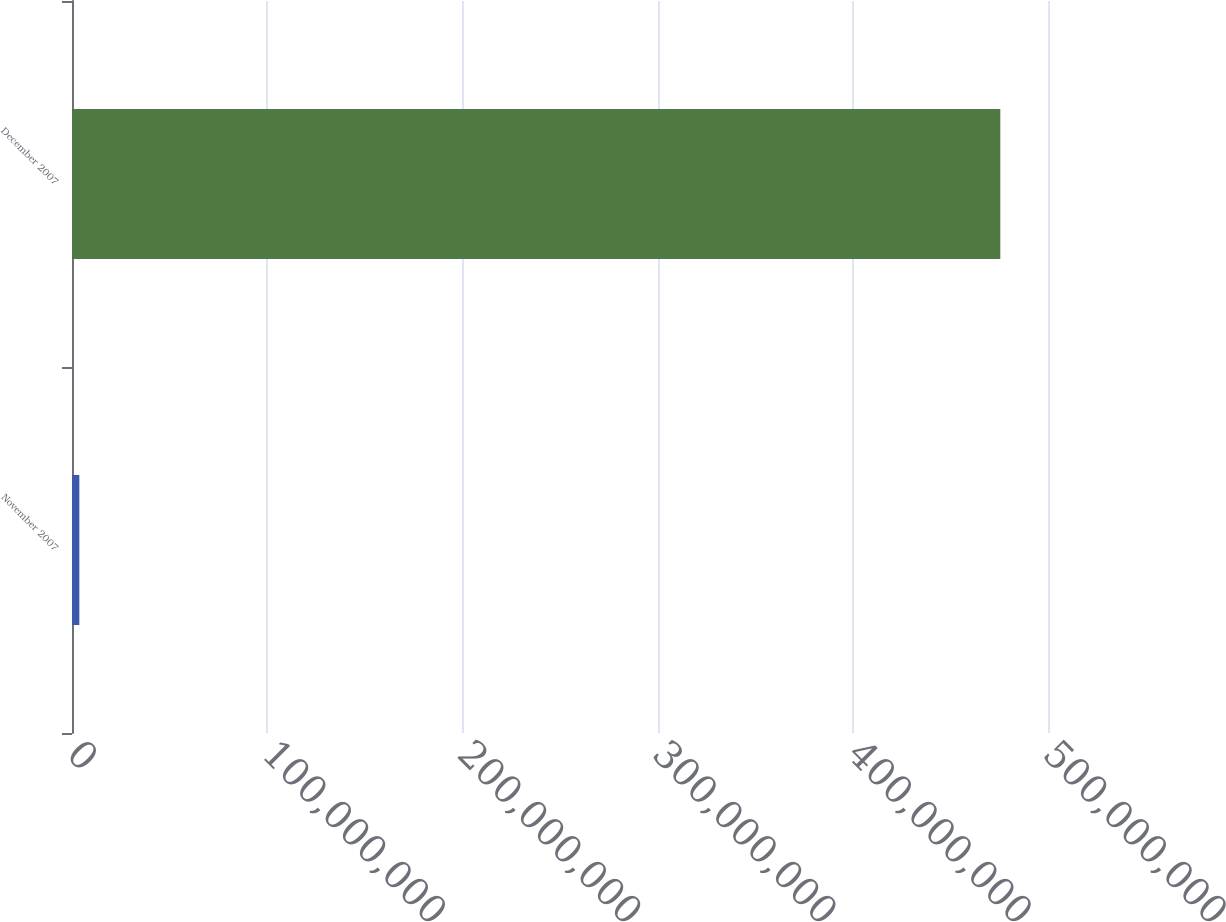Convert chart. <chart><loc_0><loc_0><loc_500><loc_500><bar_chart><fcel>November 2007<fcel>December 2007<nl><fcel>3.76267e+06<fcel>4.75569e+08<nl></chart> 